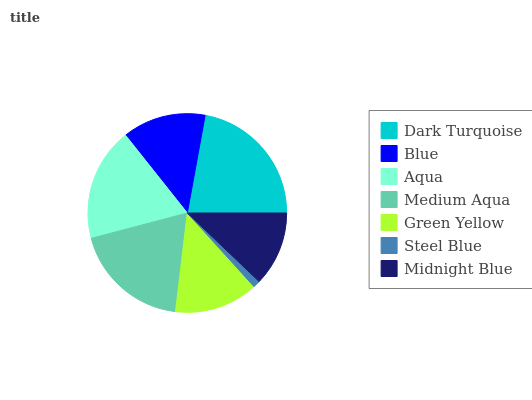Is Steel Blue the minimum?
Answer yes or no. Yes. Is Dark Turquoise the maximum?
Answer yes or no. Yes. Is Blue the minimum?
Answer yes or no. No. Is Blue the maximum?
Answer yes or no. No. Is Dark Turquoise greater than Blue?
Answer yes or no. Yes. Is Blue less than Dark Turquoise?
Answer yes or no. Yes. Is Blue greater than Dark Turquoise?
Answer yes or no. No. Is Dark Turquoise less than Blue?
Answer yes or no. No. Is Green Yellow the high median?
Answer yes or no. Yes. Is Green Yellow the low median?
Answer yes or no. Yes. Is Blue the high median?
Answer yes or no. No. Is Steel Blue the low median?
Answer yes or no. No. 